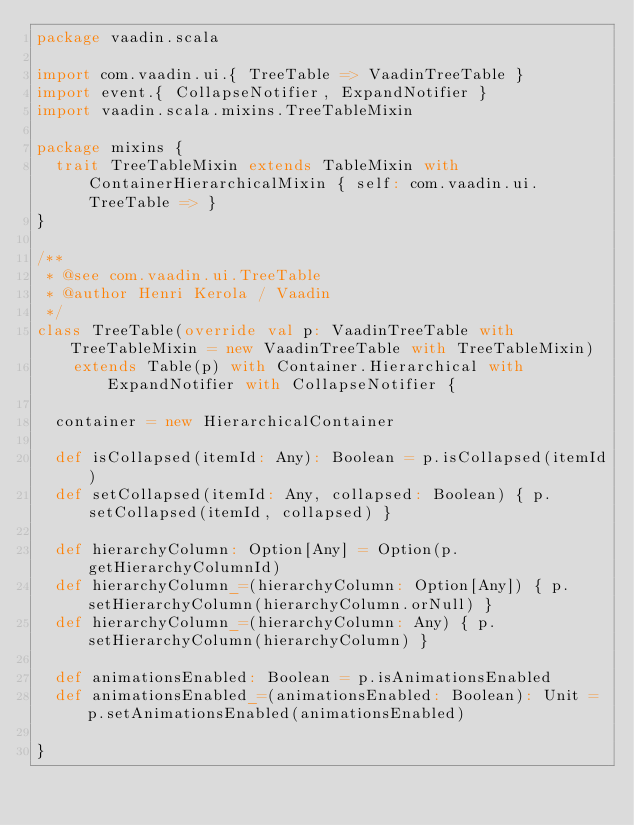Convert code to text. <code><loc_0><loc_0><loc_500><loc_500><_Scala_>package vaadin.scala

import com.vaadin.ui.{ TreeTable => VaadinTreeTable }
import event.{ CollapseNotifier, ExpandNotifier }
import vaadin.scala.mixins.TreeTableMixin

package mixins {
  trait TreeTableMixin extends TableMixin with ContainerHierarchicalMixin { self: com.vaadin.ui.TreeTable => }
}

/**
 * @see com.vaadin.ui.TreeTable
 * @author Henri Kerola / Vaadin
 */
class TreeTable(override val p: VaadinTreeTable with TreeTableMixin = new VaadinTreeTable with TreeTableMixin)
    extends Table(p) with Container.Hierarchical with ExpandNotifier with CollapseNotifier {

  container = new HierarchicalContainer

  def isCollapsed(itemId: Any): Boolean = p.isCollapsed(itemId)
  def setCollapsed(itemId: Any, collapsed: Boolean) { p.setCollapsed(itemId, collapsed) }

  def hierarchyColumn: Option[Any] = Option(p.getHierarchyColumnId)
  def hierarchyColumn_=(hierarchyColumn: Option[Any]) { p.setHierarchyColumn(hierarchyColumn.orNull) }
  def hierarchyColumn_=(hierarchyColumn: Any) { p.setHierarchyColumn(hierarchyColumn) }

  def animationsEnabled: Boolean = p.isAnimationsEnabled
  def animationsEnabled_=(animationsEnabled: Boolean): Unit = p.setAnimationsEnabled(animationsEnabled)

}</code> 